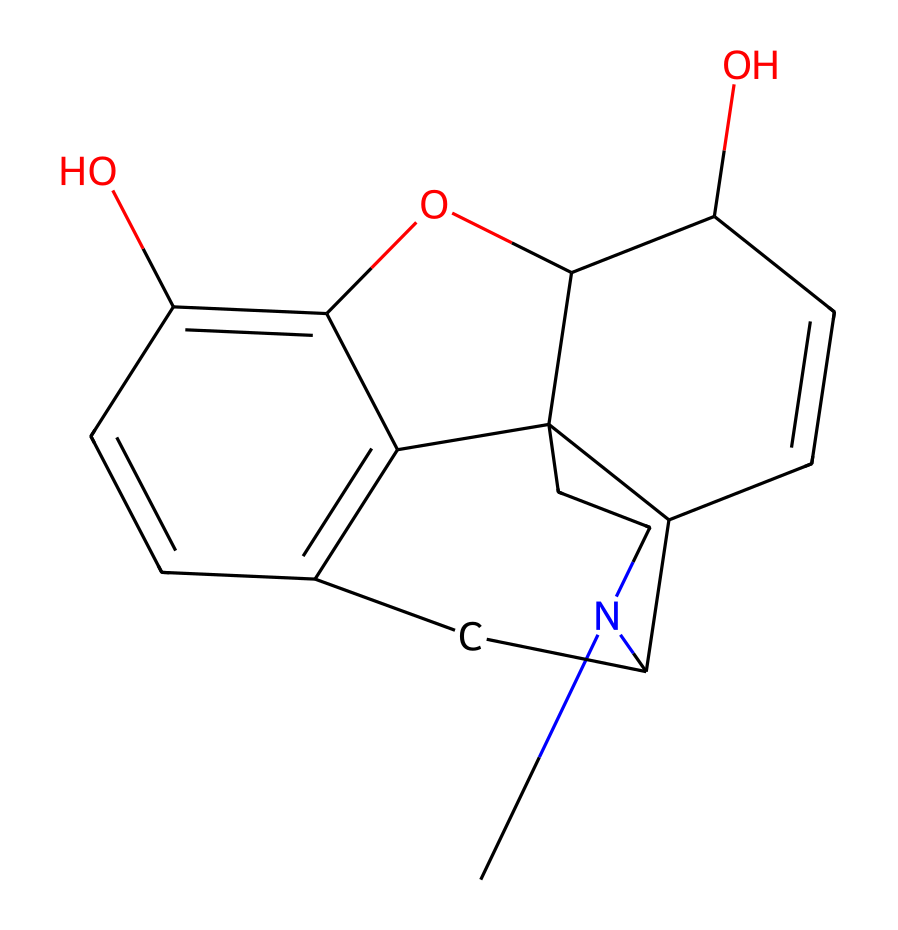How many carbon atoms are in morphine? The SMILES representation contains several groups of carbon atoms. To find the total number, we can count the 'C' characters in the SMILES. There are 17 carbon atoms present in the structure.
Answer: 17 How many nitrogen atoms are present? In the SMILES notation, nitrogen atoms are represented by 'N'. By examining the SMILES, we can see there is only one 'N' character present, indicating there is one nitrogen atom.
Answer: 1 What is the molecular formula of morphine? To derive the molecular formula, we can interpret the SMILES and count the number of each type of atom: C (17), H (19), N (1), O (2). Thus, the molecular formula is C17H19NO2.
Answer: C17H19NO2 Does morphine have a hydroxyl group? Hydroxyl groups are characterized by the presence of an -OH group. In the SMILES, there are two occurrences of 'O' that could be part of hydroxyl groups. The structure confirms the presence of hydroxyl (-OH) groups.
Answer: Yes What type of chemical is morphine classified as? Given that morphine is derived from opium poppy and exhibits alkaline properties along with a specific nitrogen-containing structure, it is classified as an alkaloid.
Answer: Alkaloid Which atoms in morphine could participate in hydrogen bonding? Atoms that can typically participate in hydrogen bonding are those with high electronegativity, such as N and O. In morphine, the presence of nitrogen and the two hydroxyl oxygens suggests that hydrogen bonding is possible through these atoms.
Answer: N and O 